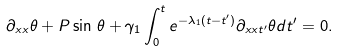Convert formula to latex. <formula><loc_0><loc_0><loc_500><loc_500>\partial _ { x x } \theta + P \sin \, \theta + \gamma _ { 1 } \int _ { 0 } ^ { t } e ^ { - \lambda _ { 1 } ( t - t ^ { \prime } ) } \partial _ { x x t ^ { \prime } } \theta d t ^ { \prime } = 0 .</formula> 